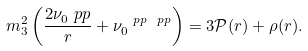Convert formula to latex. <formula><loc_0><loc_0><loc_500><loc_500>m _ { 3 } ^ { 2 } \left ( \frac { 2 \nu _ { 0 } ^ { \ } p p } { r } + \nu _ { 0 } ^ { \ p p \ p p } \right ) = 3 \mathcal { P } ( r ) + \rho ( r ) .</formula> 